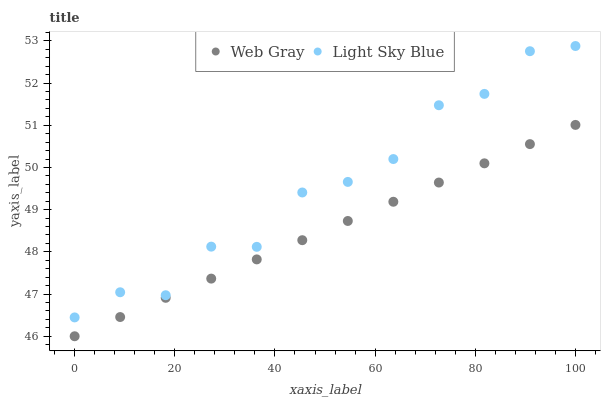Does Web Gray have the minimum area under the curve?
Answer yes or no. Yes. Does Light Sky Blue have the maximum area under the curve?
Answer yes or no. Yes. Does Light Sky Blue have the minimum area under the curve?
Answer yes or no. No. Is Web Gray the smoothest?
Answer yes or no. Yes. Is Light Sky Blue the roughest?
Answer yes or no. Yes. Is Light Sky Blue the smoothest?
Answer yes or no. No. Does Web Gray have the lowest value?
Answer yes or no. Yes. Does Light Sky Blue have the lowest value?
Answer yes or no. No. Does Light Sky Blue have the highest value?
Answer yes or no. Yes. Is Web Gray less than Light Sky Blue?
Answer yes or no. Yes. Is Light Sky Blue greater than Web Gray?
Answer yes or no. Yes. Does Web Gray intersect Light Sky Blue?
Answer yes or no. No. 